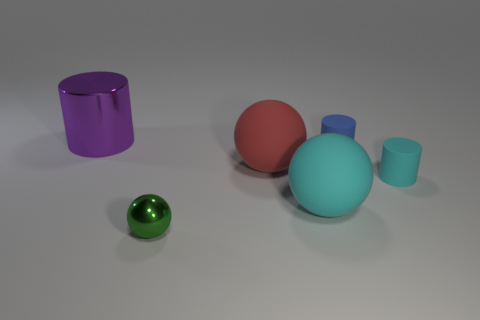Are there fewer big shiny cylinders in front of the small metal sphere than big gray metallic balls?
Offer a very short reply. No. Is the number of small green shiny objects in front of the big red rubber sphere greater than the number of small green metal things that are to the right of the large cyan rubber sphere?
Make the answer very short. Yes. Is there any other thing that is the same color as the shiny cylinder?
Make the answer very short. No. What is the cylinder that is to the right of the blue thing made of?
Provide a short and direct response. Rubber. Is the size of the blue object the same as the purple shiny thing?
Your answer should be very brief. No. What number of other things are the same size as the blue cylinder?
Your answer should be very brief. 2. Do the tiny metal ball and the big metallic thing have the same color?
Your answer should be very brief. No. What shape is the metallic object that is left of the metal object in front of the metal object behind the green metallic sphere?
Your response must be concise. Cylinder. How many things are either large things that are on the right side of the large red thing or cyan rubber cylinders in front of the blue rubber thing?
Provide a short and direct response. 2. What size is the object that is left of the metallic object that is to the right of the large shiny thing?
Give a very brief answer. Large. 